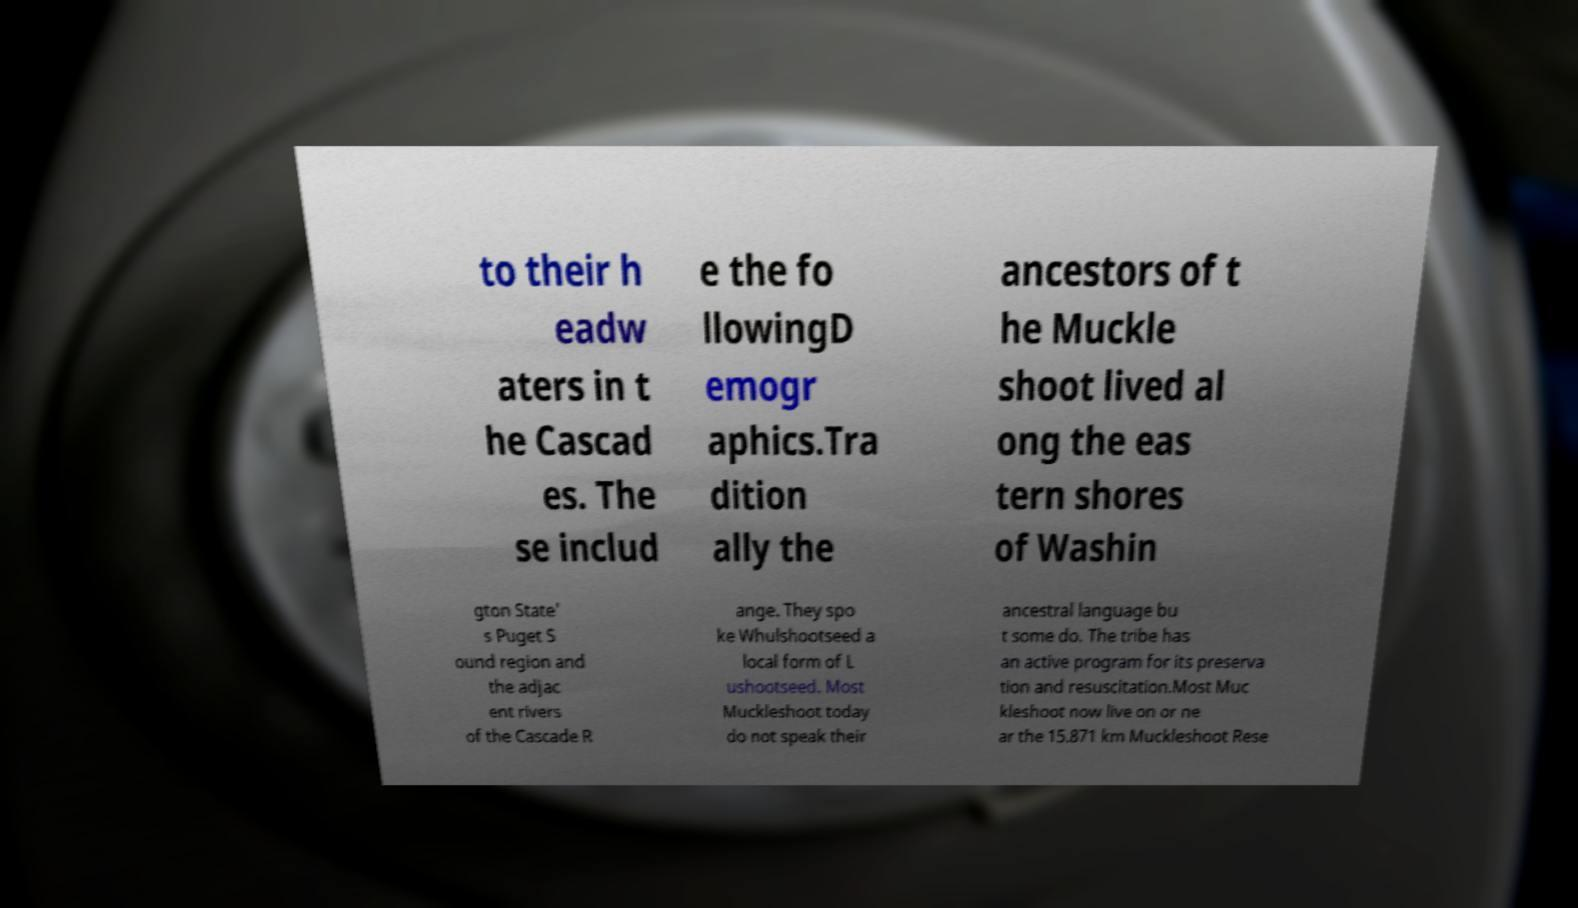There's text embedded in this image that I need extracted. Can you transcribe it verbatim? to their h eadw aters in t he Cascad es. The se includ e the fo llowingD emogr aphics.Tra dition ally the ancestors of t he Muckle shoot lived al ong the eas tern shores of Washin gton State' s Puget S ound region and the adjac ent rivers of the Cascade R ange. They spo ke Whulshootseed a local form of L ushootseed. Most Muckleshoot today do not speak their ancestral language bu t some do. The tribe has an active program for its preserva tion and resuscitation.Most Muc kleshoot now live on or ne ar the 15.871 km Muckleshoot Rese 